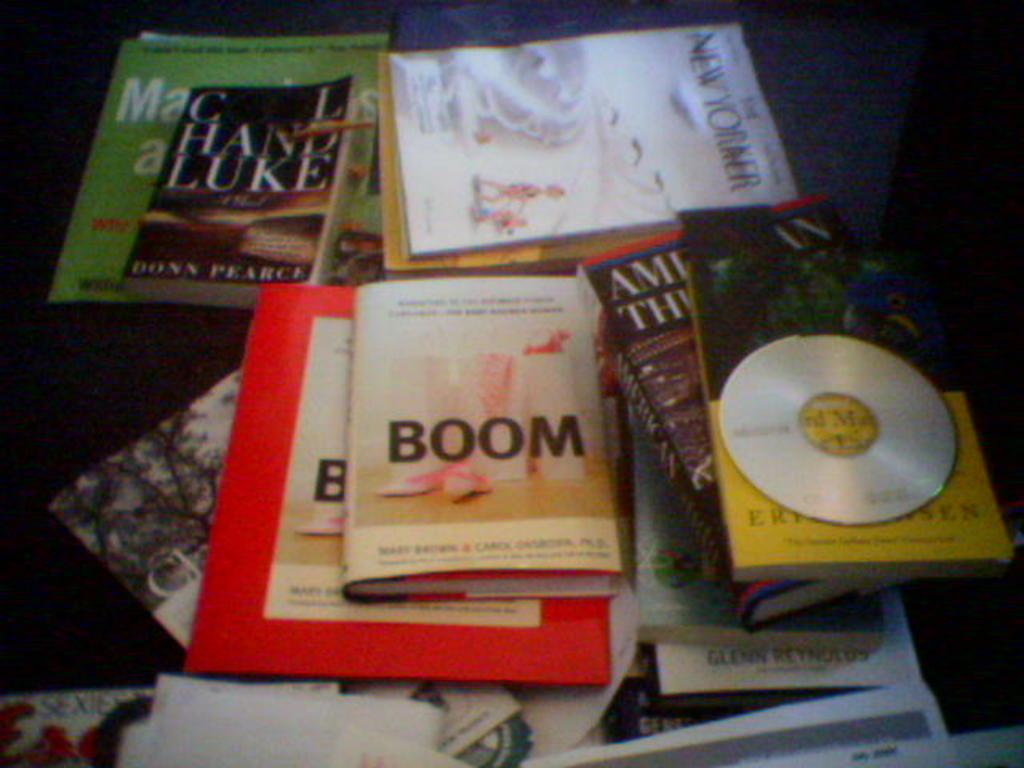<image>
Render a clear and concise summary of the photo. A variety of books on a table with one of the books called Boom. 